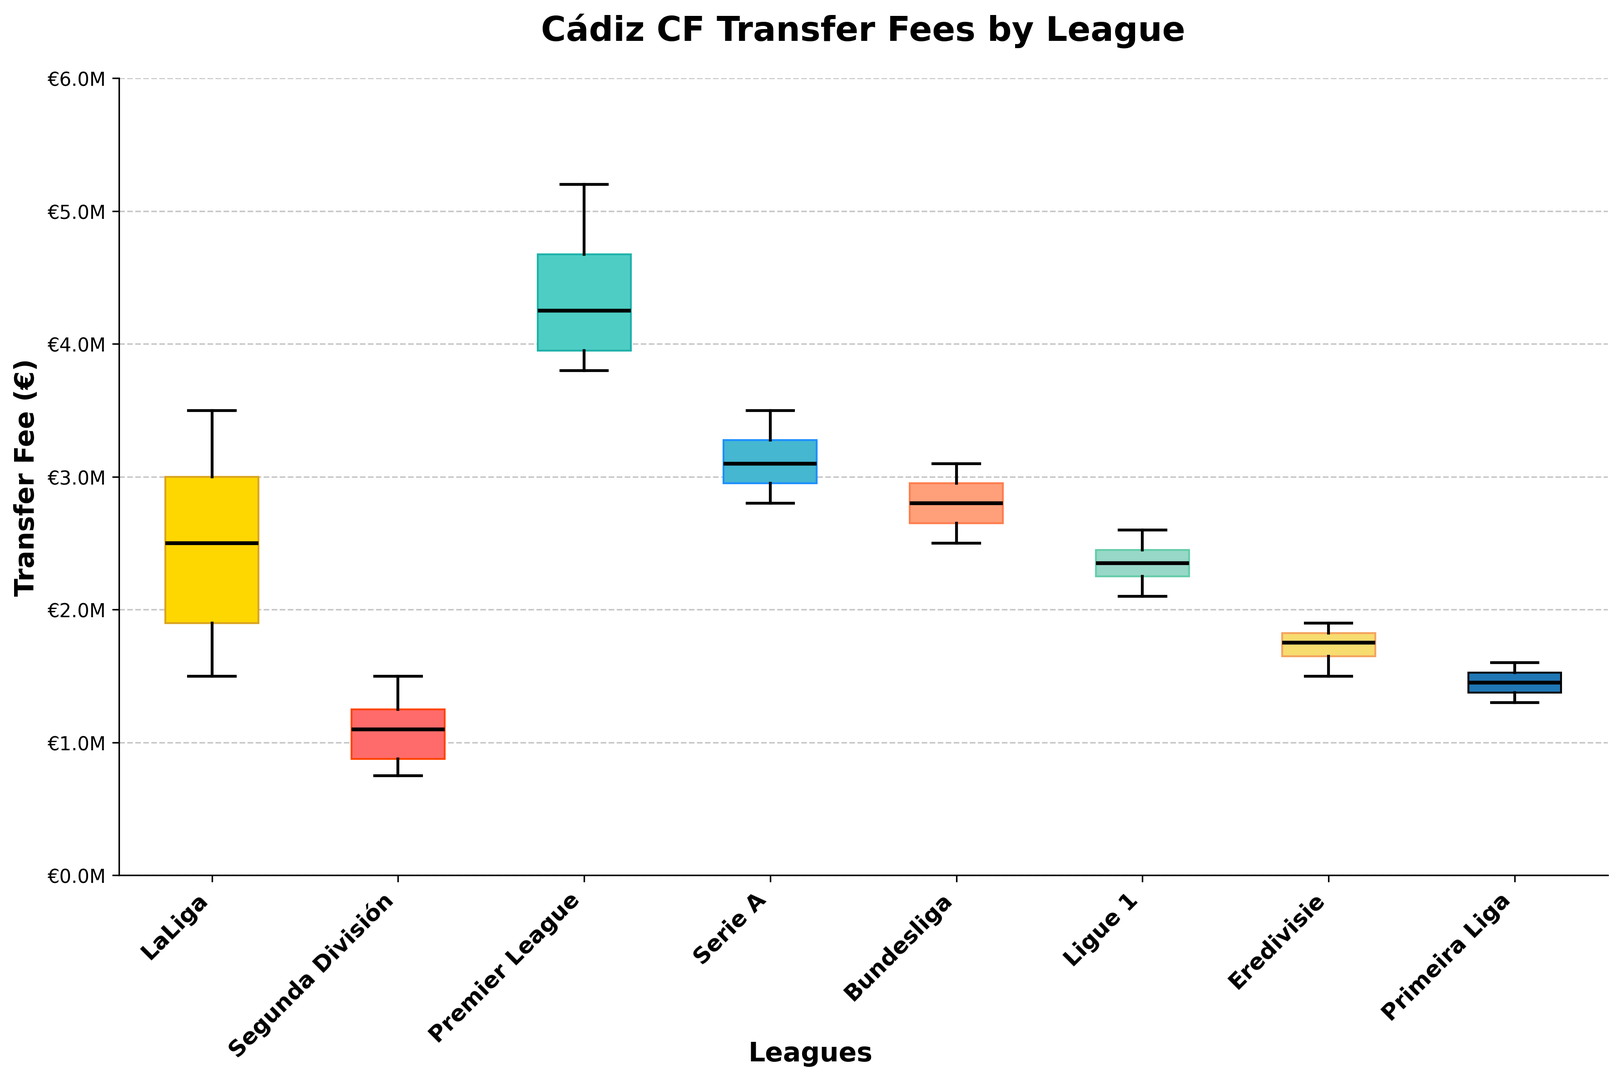Which league has the highest median transfer fee? From the box plot, identify the league with the highest black line (representing the median).
Answer: Premier League What is the interquartile range (IQR) for LaLiga? The IQR is the difference between the upper quartile (75th percentile) and the lower quartile (25th percentile). Identify these points from LaLiga's box, then subtract the lower quartile value from the upper quartile value.
Answer: €1,300,000 Which league has the smallest range of transfer fees? Look for the league with the shortest distance between the top of the whisker and the bottom of the whisker.
Answer: Segunda División How does the median transfer fee of Serie A compare to that of LaLiga? Compare the height of the median (black line) in Serie A's box plot to that of LaLiga's. Note the specific fee values.
Answer: The Series A median is higher Are any transfer fees for Premier League players considered outliers? Check if there are any individual dots outside the whiskers of the Premier League's box, which represent outliers.
Answer: No What is the maximum transfer fee paid for a player from Bundesliga? Identify the top whisker or the highest point if there are outliers in Bundesliga's box plot.
Answer: €3,100,000 What does the distribution of transfer fees from Ligue 1 look like compared to Eredivisie? Compare the size and position of the boxes and whiskers for Ligue 1 and Eredivisie to infer the spread and central tendency of transfer fees.
Answer: Ligue 1's fees are slightly higher and more compact Which league has the lowest median transfer fee? Locate the league with the lowest position of the black median line.
Answer: Primeira Liga How many leagues have a median transfer fee greater than €2,500,000? Look at each league's median line and count how many are above the €2,500,000 mark on the y-axis.
Answer: Four leagues 